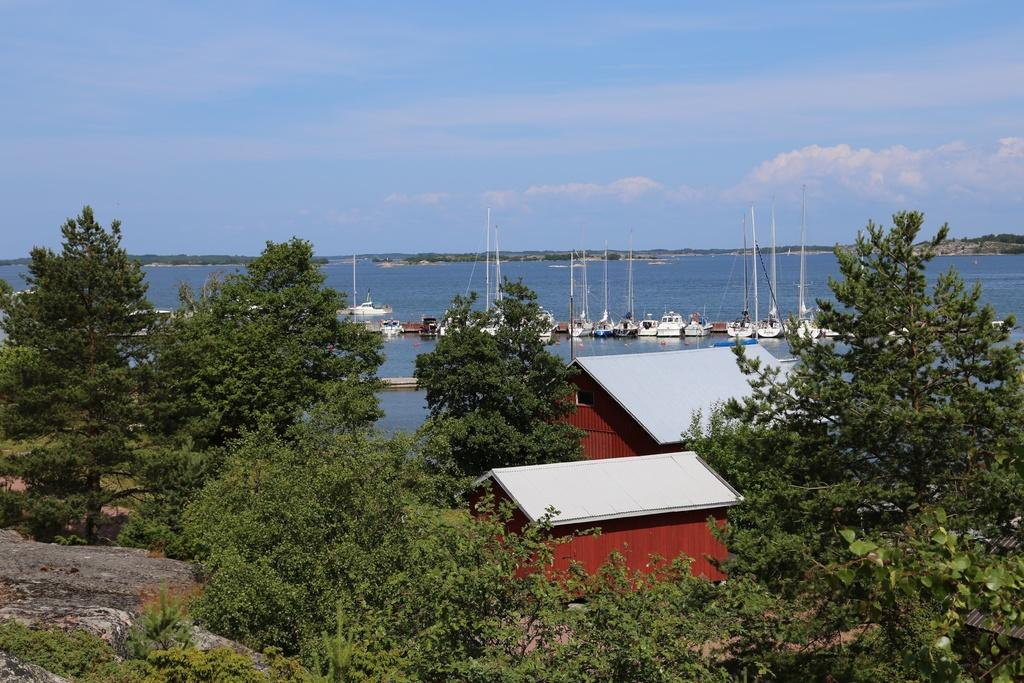What type of structures can be seen in the image? There are houses in the image. What natural elements are present in the image? There are trees in the image. What is the water in the image being used for? There are ships on the water in the image, suggesting that it is a body of water for transportation. What is the color of the sky in the image? The sky is blue and white in color. Where is the coat hanging in the image? There is no coat present in the image. What type of grass can be seen growing near the trees in the image? There is no grass visible in the image; only trees are mentioned. 